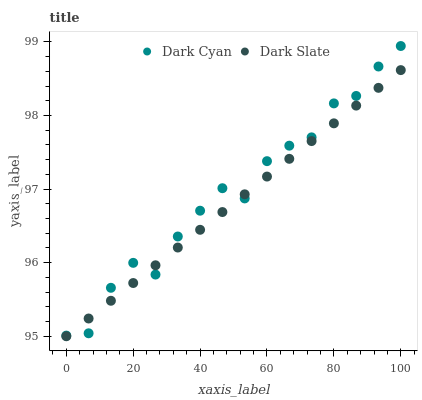Does Dark Slate have the minimum area under the curve?
Answer yes or no. Yes. Does Dark Cyan have the maximum area under the curve?
Answer yes or no. Yes. Does Dark Slate have the maximum area under the curve?
Answer yes or no. No. Is Dark Slate the smoothest?
Answer yes or no. Yes. Is Dark Cyan the roughest?
Answer yes or no. Yes. Is Dark Slate the roughest?
Answer yes or no. No. Does Dark Slate have the lowest value?
Answer yes or no. Yes. Does Dark Cyan have the highest value?
Answer yes or no. Yes. Does Dark Slate have the highest value?
Answer yes or no. No. Does Dark Cyan intersect Dark Slate?
Answer yes or no. Yes. Is Dark Cyan less than Dark Slate?
Answer yes or no. No. Is Dark Cyan greater than Dark Slate?
Answer yes or no. No. 